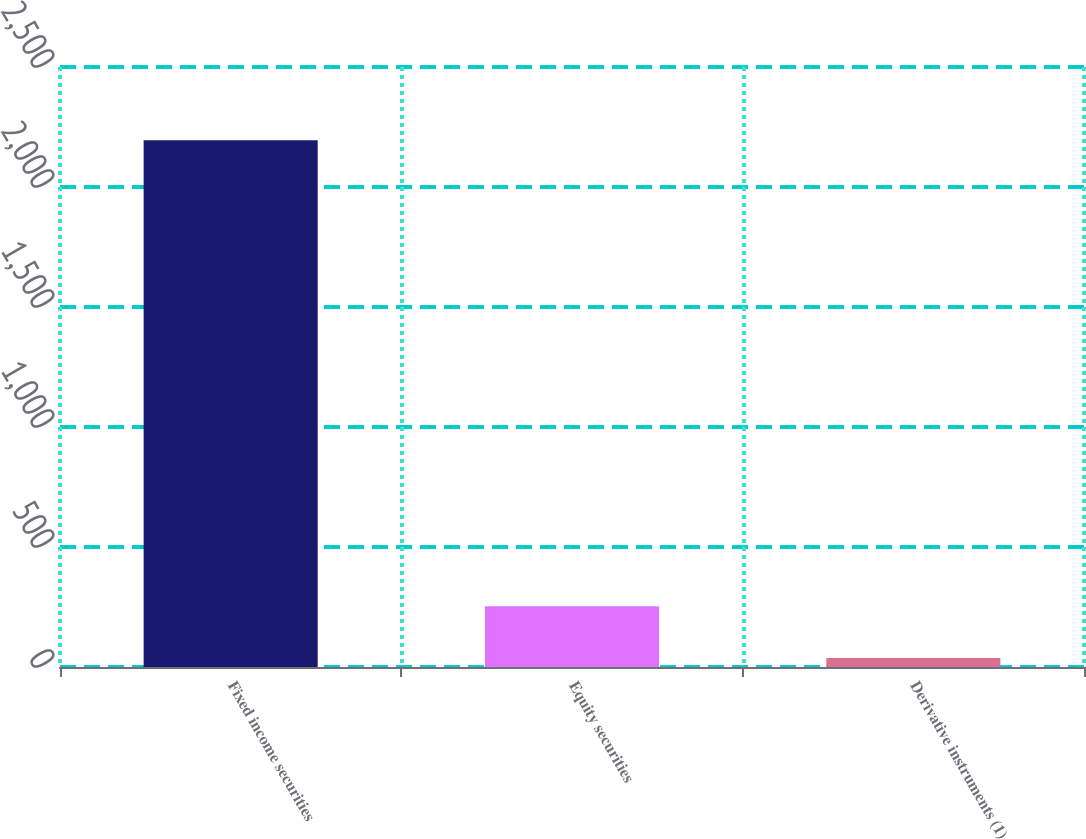Convert chart. <chart><loc_0><loc_0><loc_500><loc_500><bar_chart><fcel>Fixed income securities<fcel>Equity securities<fcel>Derivative instruments (1)<nl><fcel>2195<fcel>252.8<fcel>37<nl></chart> 